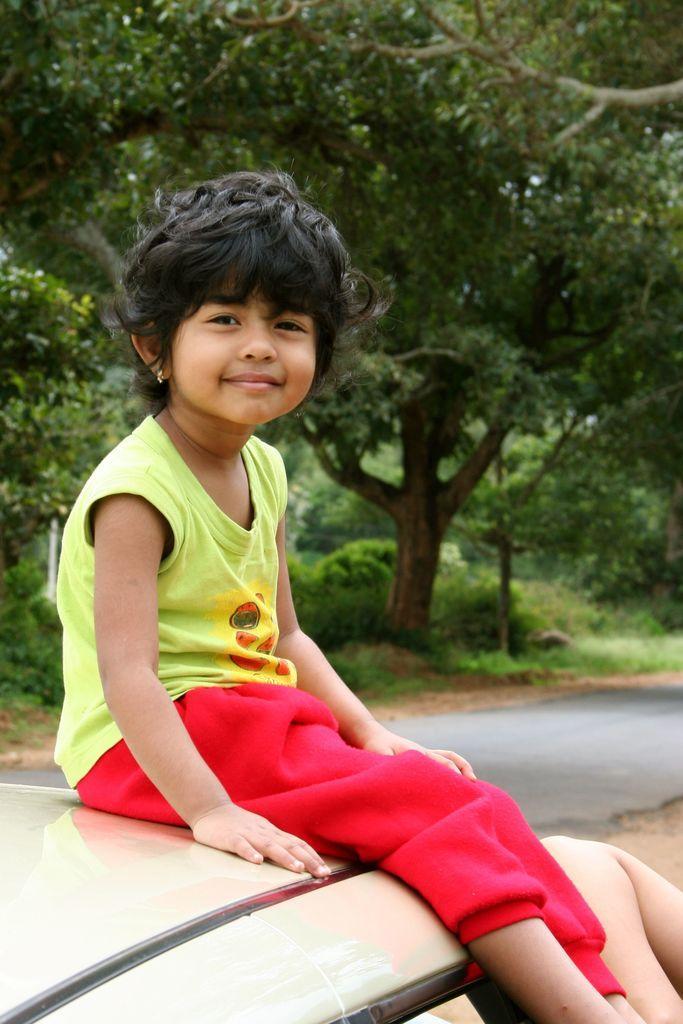Please provide a concise description of this image. Here I can see a girl wearing t-shirt and sitting on the car. The girl is smiling and giving pose for the picture. In the bottom right, I can see a person's hand. In the background, I can see the road and many trees. 